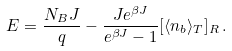Convert formula to latex. <formula><loc_0><loc_0><loc_500><loc_500>E = \frac { N _ { B } J } { q } - \frac { J e ^ { \beta J } } { e ^ { \beta J } - 1 } [ \langle n _ { b } \rangle _ { T } ] _ { R } \, .</formula> 